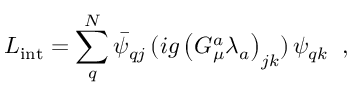<formula> <loc_0><loc_0><loc_500><loc_500>L _ { i n t } = \sum _ { q } ^ { N } \bar { \psi } _ { q j } \, ( i g \left ( G _ { \mu } ^ { a } \lambda _ { a } \right ) _ { j k } ) \, \psi _ { q k } \, ,</formula> 